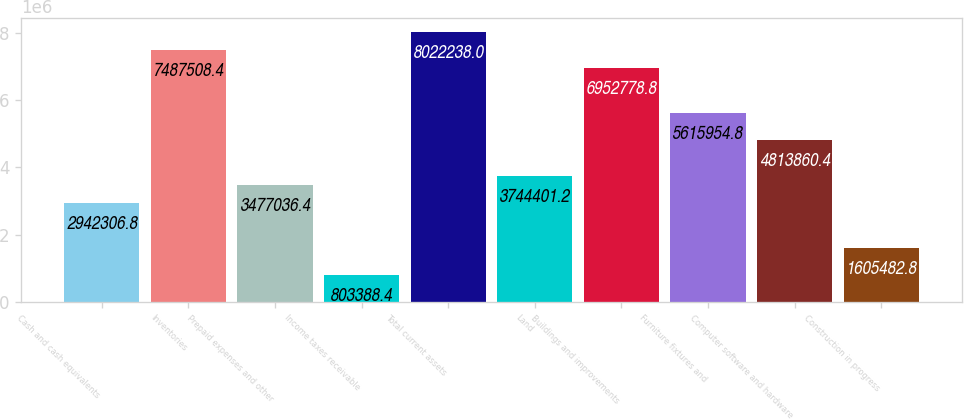<chart> <loc_0><loc_0><loc_500><loc_500><bar_chart><fcel>Cash and cash equivalents<fcel>Inventories<fcel>Prepaid expenses and other<fcel>Income taxes receivable<fcel>Total current assets<fcel>Land<fcel>Buildings and improvements<fcel>Furniture fixtures and<fcel>Computer software and hardware<fcel>Construction in progress<nl><fcel>2.94231e+06<fcel>7.48751e+06<fcel>3.47704e+06<fcel>803388<fcel>8.02224e+06<fcel>3.7444e+06<fcel>6.95278e+06<fcel>5.61595e+06<fcel>4.81386e+06<fcel>1.60548e+06<nl></chart> 